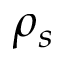Convert formula to latex. <formula><loc_0><loc_0><loc_500><loc_500>\rho _ { s }</formula> 